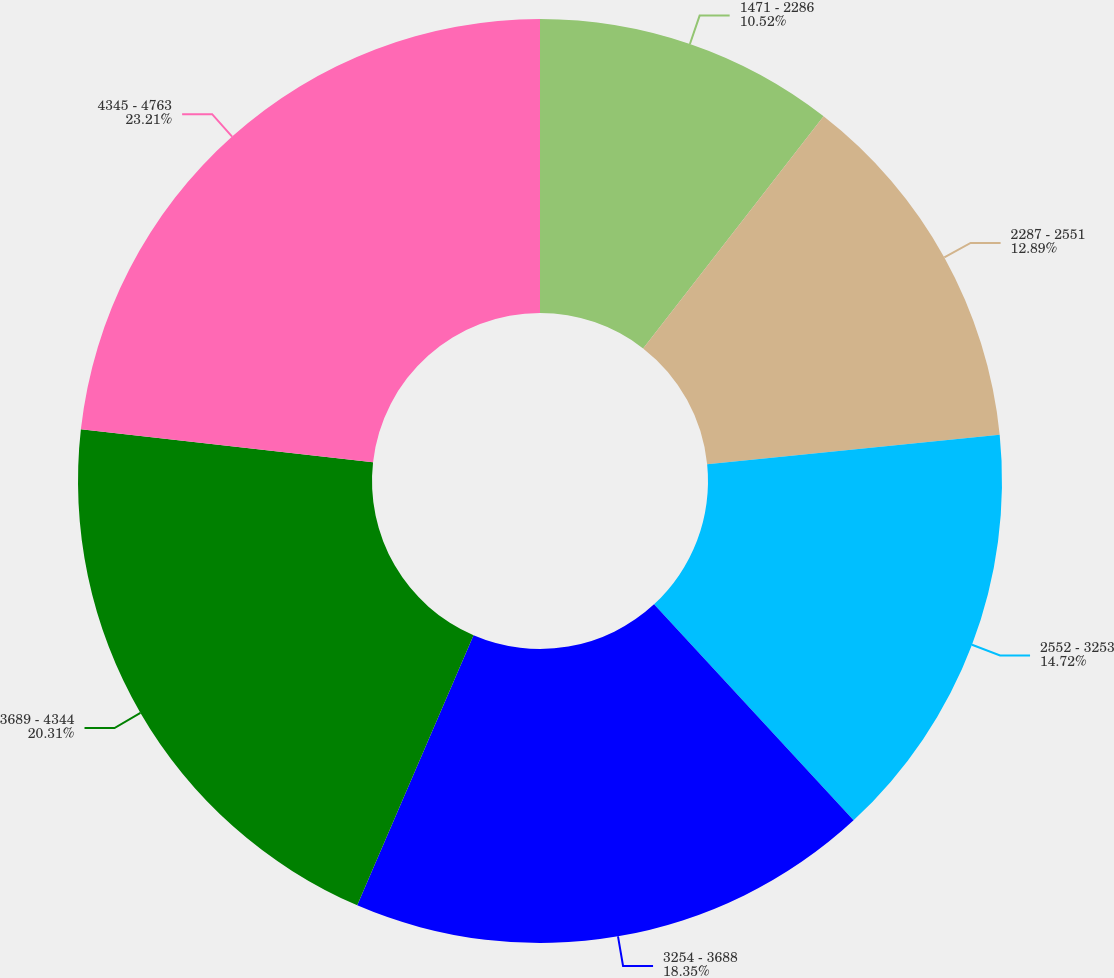Convert chart. <chart><loc_0><loc_0><loc_500><loc_500><pie_chart><fcel>1471 - 2286<fcel>2287 - 2551<fcel>2552 - 3253<fcel>3254 - 3688<fcel>3689 - 4344<fcel>4345 - 4763<nl><fcel>10.52%<fcel>12.89%<fcel>14.72%<fcel>18.35%<fcel>20.31%<fcel>23.22%<nl></chart> 